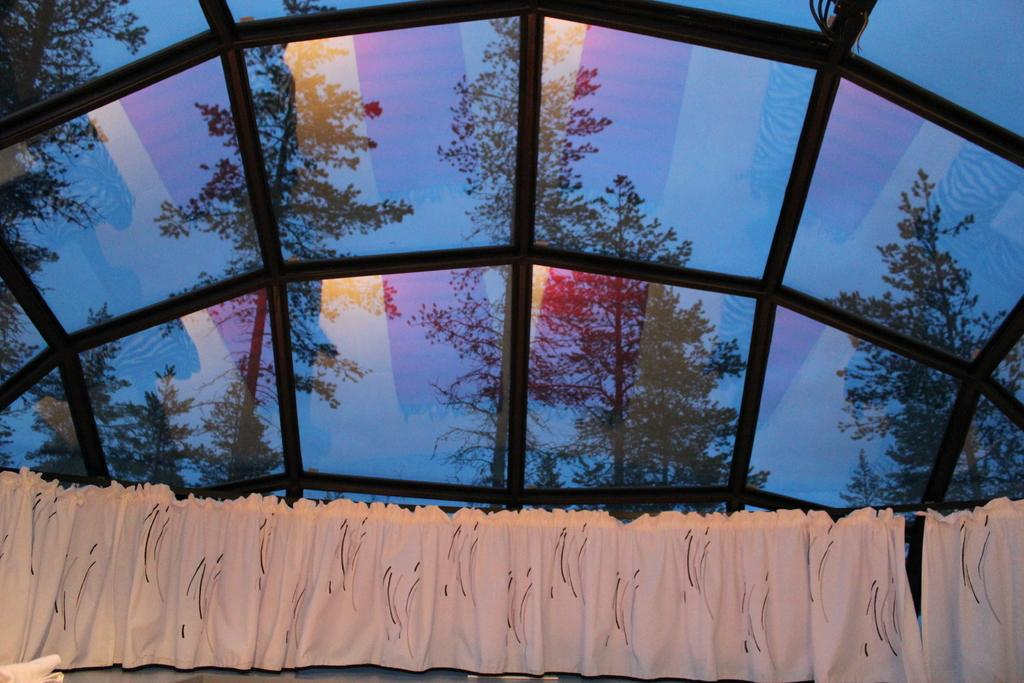What type of window treatment is visible in the image? There are curtains in the image. What material is present in the image that is typically transparent? There is glass in the image. What type of natural vegetation can be seen in the image? There are trees in the image. What type of structural element is present in the image? There are metal rods in the image. What type of stove is visible in the image? There is no stove present in the image. What type of pleasure can be seen being experienced by the passenger in the image? There is no passenger present in the image, and therefore no pleasure can be observed. 